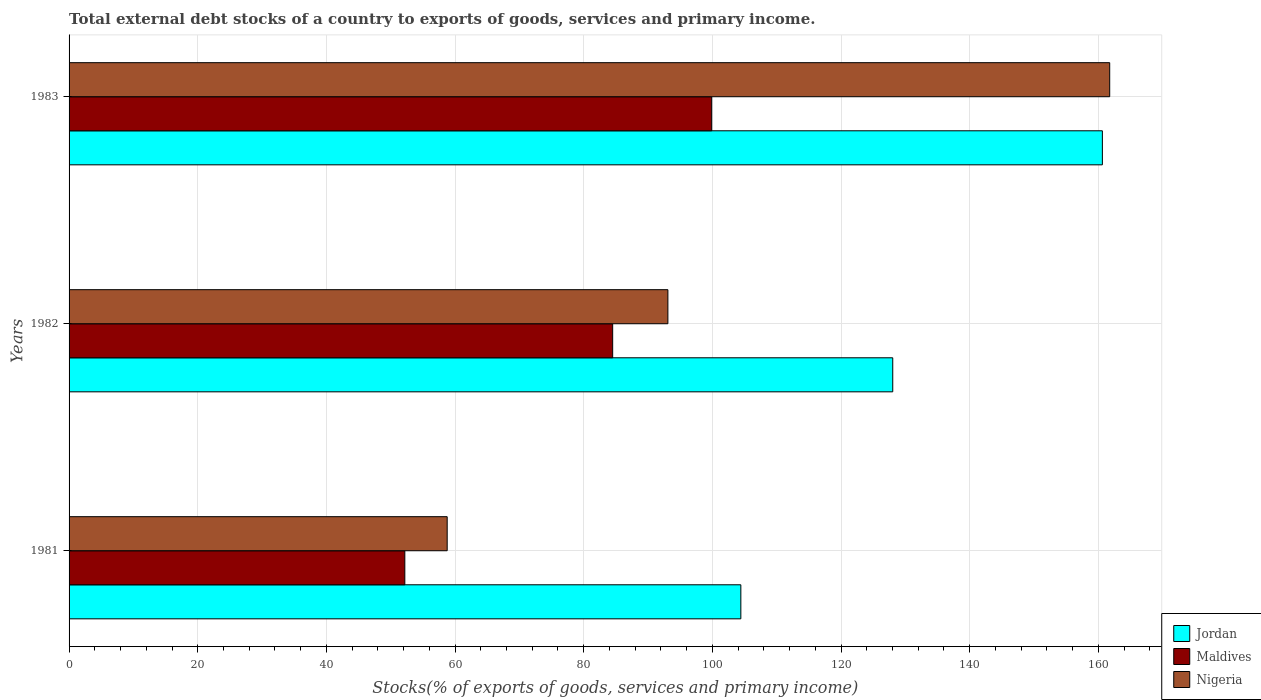Are the number of bars per tick equal to the number of legend labels?
Keep it short and to the point. Yes. Are the number of bars on each tick of the Y-axis equal?
Provide a short and direct response. Yes. How many bars are there on the 2nd tick from the top?
Offer a terse response. 3. How many bars are there on the 1st tick from the bottom?
Make the answer very short. 3. What is the label of the 2nd group of bars from the top?
Your answer should be compact. 1982. In how many cases, is the number of bars for a given year not equal to the number of legend labels?
Your response must be concise. 0. What is the total debt stocks in Jordan in 1983?
Your answer should be compact. 160.63. Across all years, what is the maximum total debt stocks in Nigeria?
Offer a very short reply. 161.77. Across all years, what is the minimum total debt stocks in Maldives?
Make the answer very short. 52.2. What is the total total debt stocks in Jordan in the graph?
Offer a very short reply. 393.11. What is the difference between the total debt stocks in Maldives in 1982 and that in 1983?
Give a very brief answer. -15.39. What is the difference between the total debt stocks in Nigeria in 1981 and the total debt stocks in Maldives in 1982?
Provide a short and direct response. -25.73. What is the average total debt stocks in Nigeria per year?
Make the answer very short. 104.55. In the year 1981, what is the difference between the total debt stocks in Nigeria and total debt stocks in Maldives?
Your response must be concise. 6.58. In how many years, is the total debt stocks in Maldives greater than 80 %?
Your answer should be very brief. 2. What is the ratio of the total debt stocks in Jordan in 1981 to that in 1983?
Ensure brevity in your answer.  0.65. Is the total debt stocks in Maldives in 1981 less than that in 1983?
Your answer should be compact. Yes. Is the difference between the total debt stocks in Nigeria in 1981 and 1983 greater than the difference between the total debt stocks in Maldives in 1981 and 1983?
Offer a terse response. No. What is the difference between the highest and the second highest total debt stocks in Jordan?
Offer a terse response. 32.59. What is the difference between the highest and the lowest total debt stocks in Jordan?
Provide a short and direct response. 56.2. What does the 1st bar from the top in 1983 represents?
Make the answer very short. Nigeria. What does the 1st bar from the bottom in 1983 represents?
Your answer should be compact. Jordan. How many bars are there?
Your answer should be very brief. 9. Are all the bars in the graph horizontal?
Give a very brief answer. Yes. What is the difference between two consecutive major ticks on the X-axis?
Your response must be concise. 20. Are the values on the major ticks of X-axis written in scientific E-notation?
Provide a succinct answer. No. What is the title of the graph?
Offer a very short reply. Total external debt stocks of a country to exports of goods, services and primary income. Does "North America" appear as one of the legend labels in the graph?
Your answer should be compact. No. What is the label or title of the X-axis?
Ensure brevity in your answer.  Stocks(% of exports of goods, services and primary income). What is the Stocks(% of exports of goods, services and primary income) of Jordan in 1981?
Offer a very short reply. 104.43. What is the Stocks(% of exports of goods, services and primary income) of Maldives in 1981?
Provide a short and direct response. 52.2. What is the Stocks(% of exports of goods, services and primary income) in Nigeria in 1981?
Keep it short and to the point. 58.78. What is the Stocks(% of exports of goods, services and primary income) of Jordan in 1982?
Offer a terse response. 128.04. What is the Stocks(% of exports of goods, services and primary income) of Maldives in 1982?
Keep it short and to the point. 84.51. What is the Stocks(% of exports of goods, services and primary income) of Nigeria in 1982?
Your answer should be very brief. 93.09. What is the Stocks(% of exports of goods, services and primary income) of Jordan in 1983?
Provide a succinct answer. 160.63. What is the Stocks(% of exports of goods, services and primary income) of Maldives in 1983?
Make the answer very short. 99.9. What is the Stocks(% of exports of goods, services and primary income) of Nigeria in 1983?
Give a very brief answer. 161.77. Across all years, what is the maximum Stocks(% of exports of goods, services and primary income) in Jordan?
Make the answer very short. 160.63. Across all years, what is the maximum Stocks(% of exports of goods, services and primary income) in Maldives?
Provide a short and direct response. 99.9. Across all years, what is the maximum Stocks(% of exports of goods, services and primary income) of Nigeria?
Make the answer very short. 161.77. Across all years, what is the minimum Stocks(% of exports of goods, services and primary income) in Jordan?
Offer a terse response. 104.43. Across all years, what is the minimum Stocks(% of exports of goods, services and primary income) in Maldives?
Offer a terse response. 52.2. Across all years, what is the minimum Stocks(% of exports of goods, services and primary income) of Nigeria?
Make the answer very short. 58.78. What is the total Stocks(% of exports of goods, services and primary income) of Jordan in the graph?
Provide a succinct answer. 393.11. What is the total Stocks(% of exports of goods, services and primary income) in Maldives in the graph?
Give a very brief answer. 236.6. What is the total Stocks(% of exports of goods, services and primary income) of Nigeria in the graph?
Provide a short and direct response. 313.64. What is the difference between the Stocks(% of exports of goods, services and primary income) of Jordan in 1981 and that in 1982?
Provide a short and direct response. -23.61. What is the difference between the Stocks(% of exports of goods, services and primary income) of Maldives in 1981 and that in 1982?
Provide a succinct answer. -32.31. What is the difference between the Stocks(% of exports of goods, services and primary income) in Nigeria in 1981 and that in 1982?
Keep it short and to the point. -34.31. What is the difference between the Stocks(% of exports of goods, services and primary income) of Jordan in 1981 and that in 1983?
Give a very brief answer. -56.2. What is the difference between the Stocks(% of exports of goods, services and primary income) of Maldives in 1981 and that in 1983?
Offer a very short reply. -47.7. What is the difference between the Stocks(% of exports of goods, services and primary income) of Nigeria in 1981 and that in 1983?
Give a very brief answer. -102.99. What is the difference between the Stocks(% of exports of goods, services and primary income) of Jordan in 1982 and that in 1983?
Offer a terse response. -32.59. What is the difference between the Stocks(% of exports of goods, services and primary income) of Maldives in 1982 and that in 1983?
Provide a short and direct response. -15.39. What is the difference between the Stocks(% of exports of goods, services and primary income) in Nigeria in 1982 and that in 1983?
Offer a terse response. -68.68. What is the difference between the Stocks(% of exports of goods, services and primary income) of Jordan in 1981 and the Stocks(% of exports of goods, services and primary income) of Maldives in 1982?
Offer a terse response. 19.93. What is the difference between the Stocks(% of exports of goods, services and primary income) of Jordan in 1981 and the Stocks(% of exports of goods, services and primary income) of Nigeria in 1982?
Offer a terse response. 11.34. What is the difference between the Stocks(% of exports of goods, services and primary income) of Maldives in 1981 and the Stocks(% of exports of goods, services and primary income) of Nigeria in 1982?
Provide a succinct answer. -40.89. What is the difference between the Stocks(% of exports of goods, services and primary income) in Jordan in 1981 and the Stocks(% of exports of goods, services and primary income) in Maldives in 1983?
Make the answer very short. 4.53. What is the difference between the Stocks(% of exports of goods, services and primary income) of Jordan in 1981 and the Stocks(% of exports of goods, services and primary income) of Nigeria in 1983?
Offer a terse response. -57.34. What is the difference between the Stocks(% of exports of goods, services and primary income) of Maldives in 1981 and the Stocks(% of exports of goods, services and primary income) of Nigeria in 1983?
Make the answer very short. -109.57. What is the difference between the Stocks(% of exports of goods, services and primary income) of Jordan in 1982 and the Stocks(% of exports of goods, services and primary income) of Maldives in 1983?
Provide a succinct answer. 28.15. What is the difference between the Stocks(% of exports of goods, services and primary income) in Jordan in 1982 and the Stocks(% of exports of goods, services and primary income) in Nigeria in 1983?
Offer a very short reply. -33.73. What is the difference between the Stocks(% of exports of goods, services and primary income) in Maldives in 1982 and the Stocks(% of exports of goods, services and primary income) in Nigeria in 1983?
Keep it short and to the point. -77.27. What is the average Stocks(% of exports of goods, services and primary income) of Jordan per year?
Ensure brevity in your answer.  131.04. What is the average Stocks(% of exports of goods, services and primary income) in Maldives per year?
Provide a succinct answer. 78.87. What is the average Stocks(% of exports of goods, services and primary income) of Nigeria per year?
Your response must be concise. 104.55. In the year 1981, what is the difference between the Stocks(% of exports of goods, services and primary income) in Jordan and Stocks(% of exports of goods, services and primary income) in Maldives?
Your answer should be very brief. 52.23. In the year 1981, what is the difference between the Stocks(% of exports of goods, services and primary income) of Jordan and Stocks(% of exports of goods, services and primary income) of Nigeria?
Keep it short and to the point. 45.65. In the year 1981, what is the difference between the Stocks(% of exports of goods, services and primary income) of Maldives and Stocks(% of exports of goods, services and primary income) of Nigeria?
Provide a succinct answer. -6.58. In the year 1982, what is the difference between the Stocks(% of exports of goods, services and primary income) in Jordan and Stocks(% of exports of goods, services and primary income) in Maldives?
Keep it short and to the point. 43.54. In the year 1982, what is the difference between the Stocks(% of exports of goods, services and primary income) of Jordan and Stocks(% of exports of goods, services and primary income) of Nigeria?
Your answer should be very brief. 34.95. In the year 1982, what is the difference between the Stocks(% of exports of goods, services and primary income) of Maldives and Stocks(% of exports of goods, services and primary income) of Nigeria?
Provide a succinct answer. -8.58. In the year 1983, what is the difference between the Stocks(% of exports of goods, services and primary income) in Jordan and Stocks(% of exports of goods, services and primary income) in Maldives?
Your response must be concise. 60.73. In the year 1983, what is the difference between the Stocks(% of exports of goods, services and primary income) of Jordan and Stocks(% of exports of goods, services and primary income) of Nigeria?
Make the answer very short. -1.14. In the year 1983, what is the difference between the Stocks(% of exports of goods, services and primary income) in Maldives and Stocks(% of exports of goods, services and primary income) in Nigeria?
Ensure brevity in your answer.  -61.87. What is the ratio of the Stocks(% of exports of goods, services and primary income) in Jordan in 1981 to that in 1982?
Provide a short and direct response. 0.82. What is the ratio of the Stocks(% of exports of goods, services and primary income) in Maldives in 1981 to that in 1982?
Offer a very short reply. 0.62. What is the ratio of the Stocks(% of exports of goods, services and primary income) in Nigeria in 1981 to that in 1982?
Offer a terse response. 0.63. What is the ratio of the Stocks(% of exports of goods, services and primary income) in Jordan in 1981 to that in 1983?
Your answer should be compact. 0.65. What is the ratio of the Stocks(% of exports of goods, services and primary income) of Maldives in 1981 to that in 1983?
Ensure brevity in your answer.  0.52. What is the ratio of the Stocks(% of exports of goods, services and primary income) in Nigeria in 1981 to that in 1983?
Ensure brevity in your answer.  0.36. What is the ratio of the Stocks(% of exports of goods, services and primary income) of Jordan in 1982 to that in 1983?
Provide a short and direct response. 0.8. What is the ratio of the Stocks(% of exports of goods, services and primary income) in Maldives in 1982 to that in 1983?
Offer a terse response. 0.85. What is the ratio of the Stocks(% of exports of goods, services and primary income) in Nigeria in 1982 to that in 1983?
Provide a short and direct response. 0.58. What is the difference between the highest and the second highest Stocks(% of exports of goods, services and primary income) of Jordan?
Your response must be concise. 32.59. What is the difference between the highest and the second highest Stocks(% of exports of goods, services and primary income) of Maldives?
Give a very brief answer. 15.39. What is the difference between the highest and the second highest Stocks(% of exports of goods, services and primary income) of Nigeria?
Provide a succinct answer. 68.68. What is the difference between the highest and the lowest Stocks(% of exports of goods, services and primary income) in Jordan?
Your answer should be very brief. 56.2. What is the difference between the highest and the lowest Stocks(% of exports of goods, services and primary income) of Maldives?
Your answer should be compact. 47.7. What is the difference between the highest and the lowest Stocks(% of exports of goods, services and primary income) in Nigeria?
Your response must be concise. 102.99. 